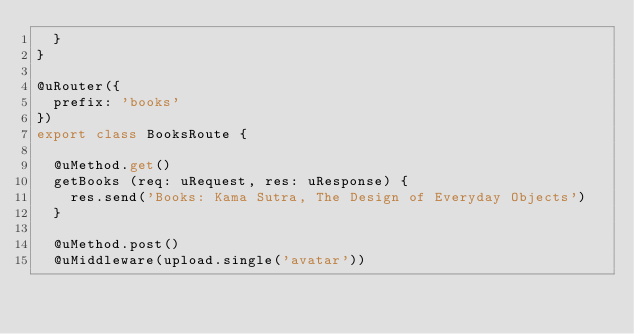<code> <loc_0><loc_0><loc_500><loc_500><_TypeScript_>  }
}

@uRouter({
  prefix: 'books'
})
export class BooksRoute {

  @uMethod.get()
  getBooks (req: uRequest, res: uResponse) {
    res.send('Books: Kama Sutra, The Design of Everyday Objects')
  }

  @uMethod.post()
  @uMiddleware(upload.single('avatar'))</code> 